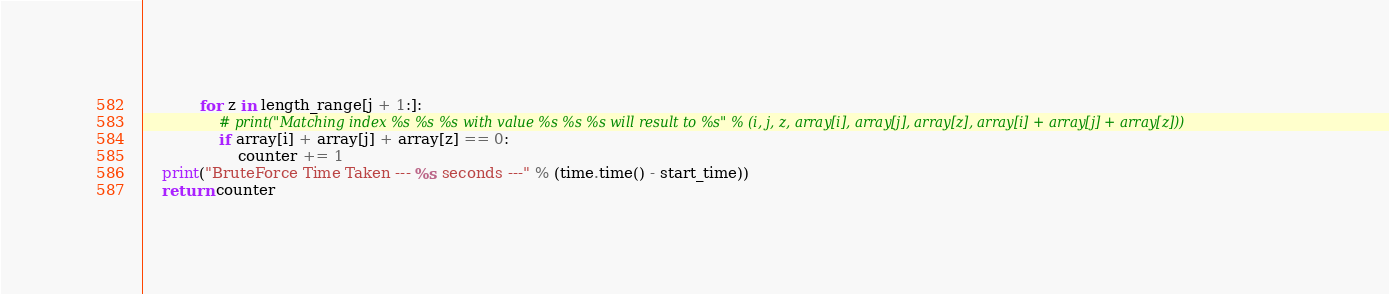<code> <loc_0><loc_0><loc_500><loc_500><_Python_>            for z in length_range[j + 1:]:
                # print("Matching index %s %s %s with value %s %s %s will result to %s" % (i, j, z, array[i], array[j], array[z], array[i] + array[j] + array[z]))
                if array[i] + array[j] + array[z] == 0:
                    counter += 1
    print("BruteForce Time Taken --- %s seconds ---" % (time.time() - start_time))
    return counter
</code> 